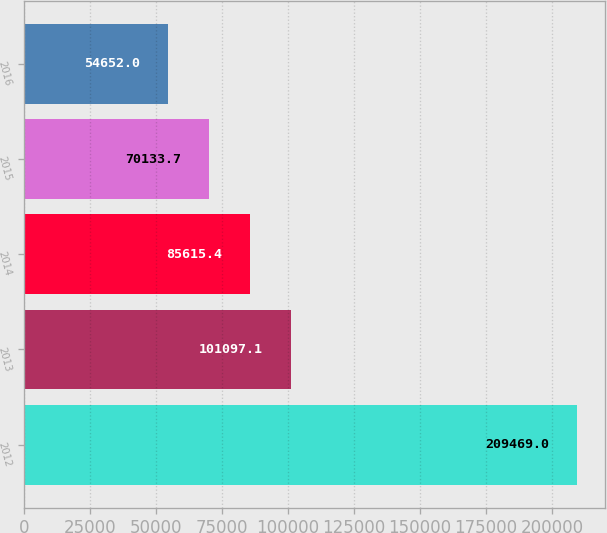<chart> <loc_0><loc_0><loc_500><loc_500><bar_chart><fcel>2012<fcel>2013<fcel>2014<fcel>2015<fcel>2016<nl><fcel>209469<fcel>101097<fcel>85615.4<fcel>70133.7<fcel>54652<nl></chart> 